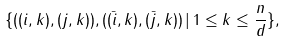Convert formula to latex. <formula><loc_0><loc_0><loc_500><loc_500>\{ ( ( i , k ) , ( j , k ) ) , ( ( \bar { i } , k ) , ( \bar { j } , k ) ) \, | \, 1 \leq k \leq \frac { n } { d } \} ,</formula> 